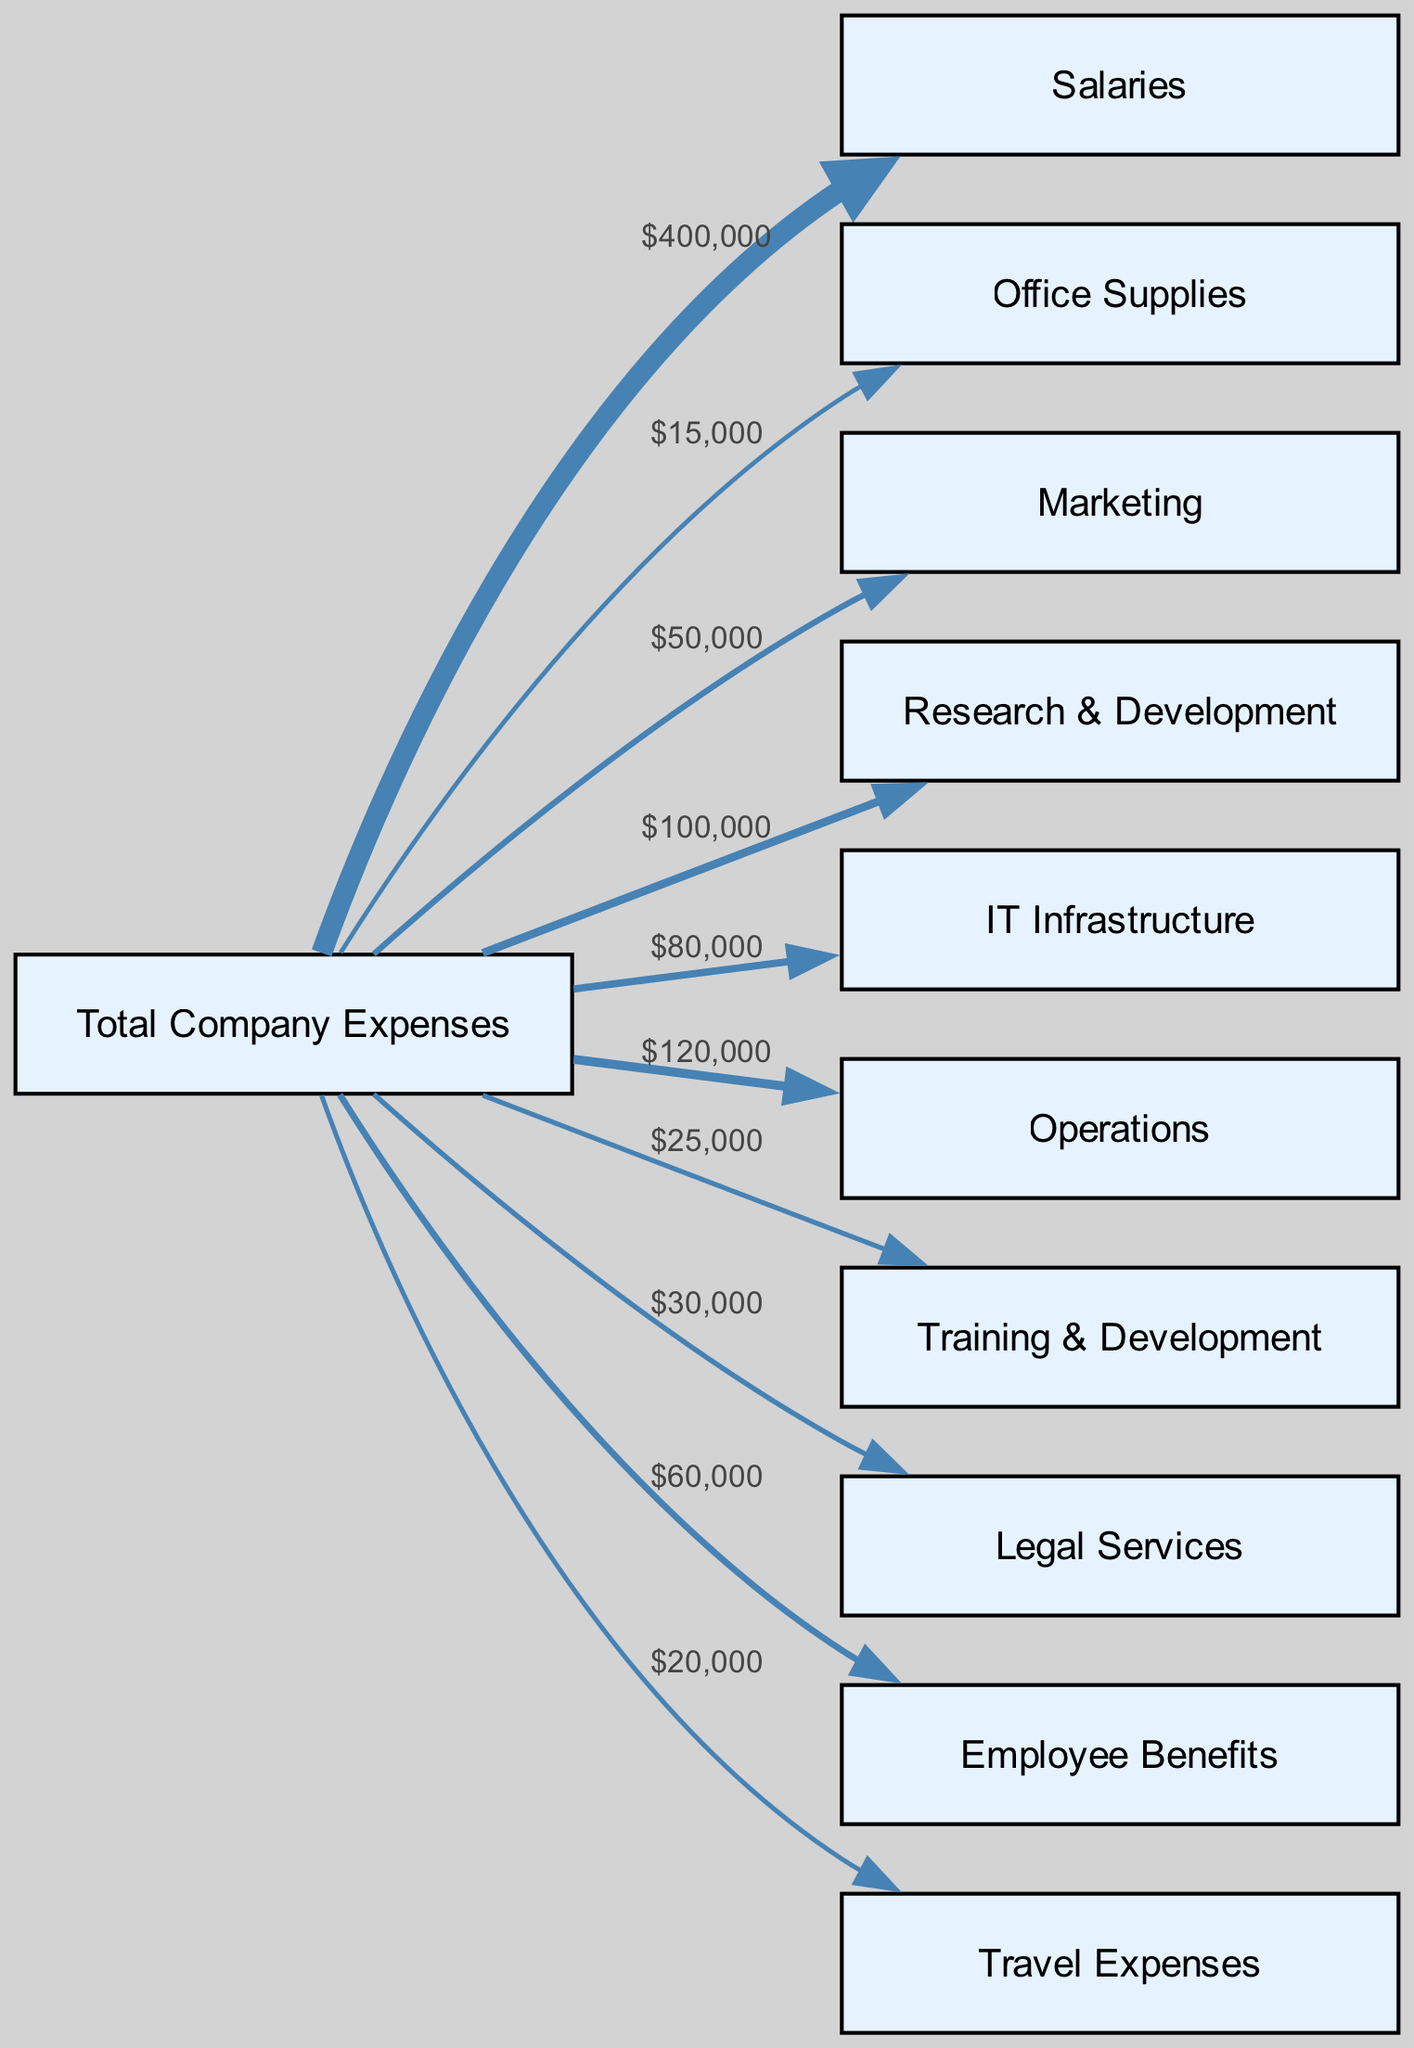What is the total amount of company expenses? The total company expenses are indicated at the start of the diagram and can be calculated by summing up all the specific expense categories. By adding the individual expenses together—$400,000 + $15,000 + $50,000 + $100,000 + $80,000 + $120,000 + $25,000 + $30,000 + $60,000 + $20,000—we conclude that the total is $1,000,000.
Answer: $1,000,000 Which category has the highest expense? The highest expense can be identified by examining the widths of the links from the "Total Company Expenses" node to the respective categories. The widest link corresponds to "Salaries," which has a value of $400,000, making it the category with the highest expense.
Answer: Salaries What percentage of total expenses is allocated to Marketing? To find the percentage of total expenses allocated to Marketing, divide the Marketing expense ($50,000) by the total expenses ($1,000,000), then multiply by 100. Thus, ($50,000 / $1,000,000) * 100 = 5%.
Answer: 5% How many expense categories are shown in the diagram? The number of expense categories can be determined by counting how many unique link targets connect to the "Total Company Expenses" node. There are ten categories: Salaries, Office Supplies, Marketing, Research & Development, IT Infrastructure, Operations, Training & Development, Legal Services, Employee Benefits, and Travel Expenses.
Answer: 10 What is the total amount spent on Employee Benefits and Travel Expenses combined? To find the combined total, add the amount spent on Employee Benefits ($60,000) and Travel Expenses ($20,000). Thus, $60,000 + $20,000 equals $80,000.
Answer: $80,000 Which department has a budget lower than $30,000? Examining the expenses, we note that "Office Supplies" ($15,000) and "Training & Development" ($25,000) are the only categories with expenses below $30,000. Thus, both departments qualify as having a budget lower than that threshold.
Answer: Office Supplies, Training & Development What fraction of the total expenses does Research & Development account for? The fraction of total expenses that Research & Development accounts for can be calculated by dividing the expense for Research & Development ($100,000) by the total company expenses ($1,000,000). Therefore, the fraction is $100,000 / $1,000,000 = 1/10.
Answer: 1/10 What distinctive feature does a Sankey Diagram have regarding expenses? A distinctive feature of a Sankey Diagram is the flow representation and width of the links between nodes, where the width of each link is proportional to the amount of the corresponding expense, visually illustrating how budget allocations are distributed across various expense categories.
Answer: Width of the links represents expense proportions 